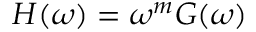<formula> <loc_0><loc_0><loc_500><loc_500>\begin{array} { r } { \begin{array} { r } { H ( \omega ) = \omega ^ { m } G ( \omega ) } \end{array} } \end{array}</formula> 